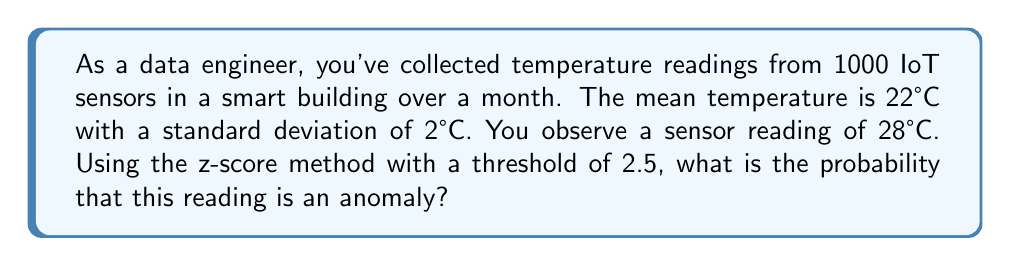Teach me how to tackle this problem. To solve this problem, we'll follow these steps:

1. Calculate the z-score for the observed temperature:
   The z-score formula is:
   $$ z = \frac{x - \mu}{\sigma} $$
   where $x$ is the observed value, $\mu$ is the mean, and $\sigma$ is the standard deviation.

   $$ z = \frac{28 - 22}{2} = 3 $$

2. Compare the calculated z-score to the threshold:
   The calculated z-score (3) is greater than the threshold (2.5), so this reading is considered an anomaly.

3. Calculate the probability of this anomaly:
   To find the probability, we need to calculate the area under the standard normal distribution curve beyond z = 2.5 (two-tailed test).

   Using the standard normal distribution table or a calculator:
   $P(|Z| > 2.5) = 2 \times P(Z > 2.5) = 2 \times 0.00621 = 0.01242$

4. Convert the probability to a percentage:
   $0.01242 \times 100\% = 1.242\%$

Therefore, the probability that this reading is an anomaly is approximately 1.242%.
Answer: 1.242% 